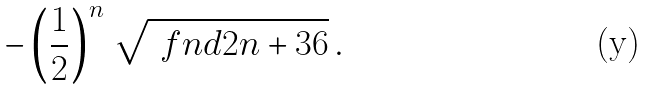<formula> <loc_0><loc_0><loc_500><loc_500>- \left ( \frac { 1 } { 2 } \right ) ^ { n } \, \sqrt { \ f n d { 2 n + 3 } { 6 } } \, .</formula> 